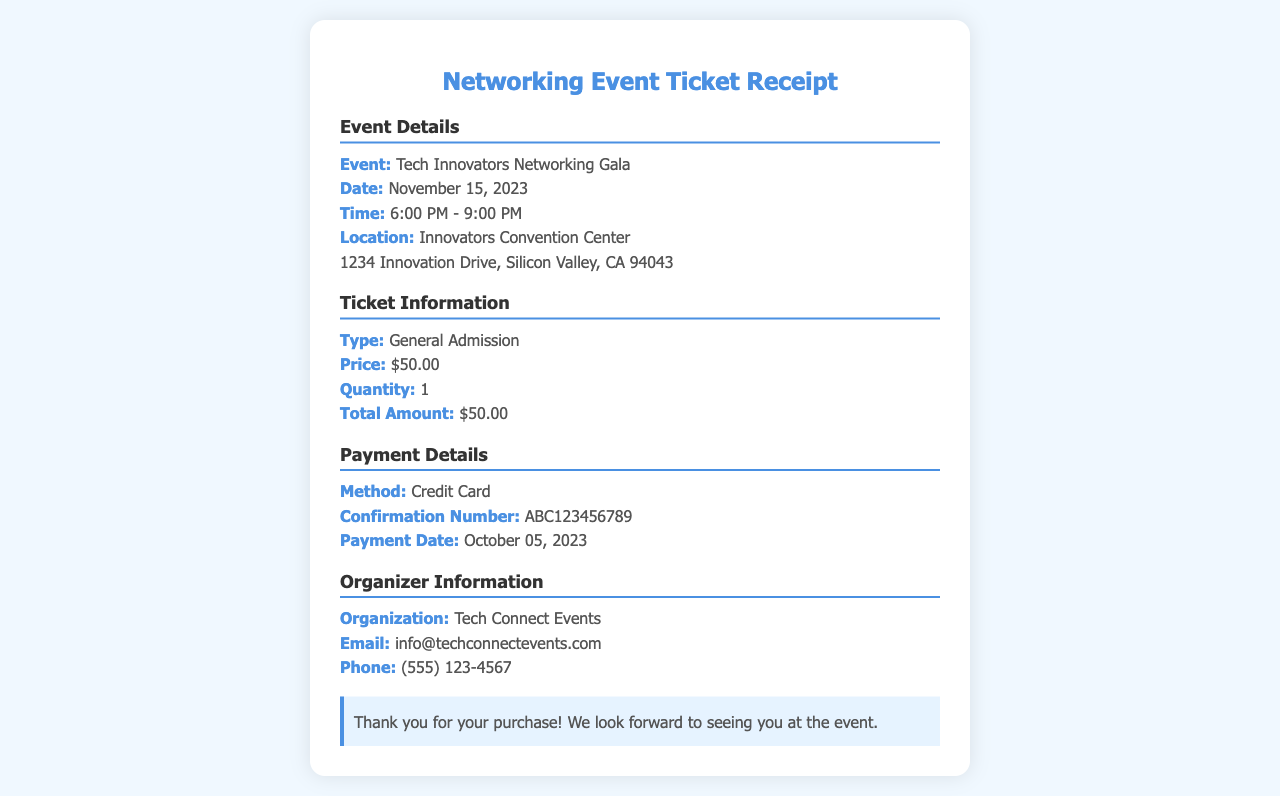What is the event name? The event name is specified in the document under the event details section.
Answer: Tech Innovators Networking Gala What is the date of the event? The date of the event is listed in the event details section of the document.
Answer: November 15, 2023 What is the ticket price? The ticket price can be found in the ticket information section of the receipt.
Answer: $50.00 What is the payment method used? The payment method is mentioned in the payment details section of the document.
Answer: Credit Card What is the confirmation number? The confirmation number is provided in the payment details section.
Answer: ABC123456789 How long is the event scheduled for? This requires extracting the time from the event details and calculating the duration.
Answer: 3 hours What is the total amount paid for the ticket? Total amount paid is clearly specified in the ticket information section of the document.
Answer: $50.00 Who is organizing the event? The organizing body is noted in the organizer information section of the receipt.
Answer: Tech Connect Events What is the location of the event? The location can be found in the event details section.
Answer: Innovators Convention Center 